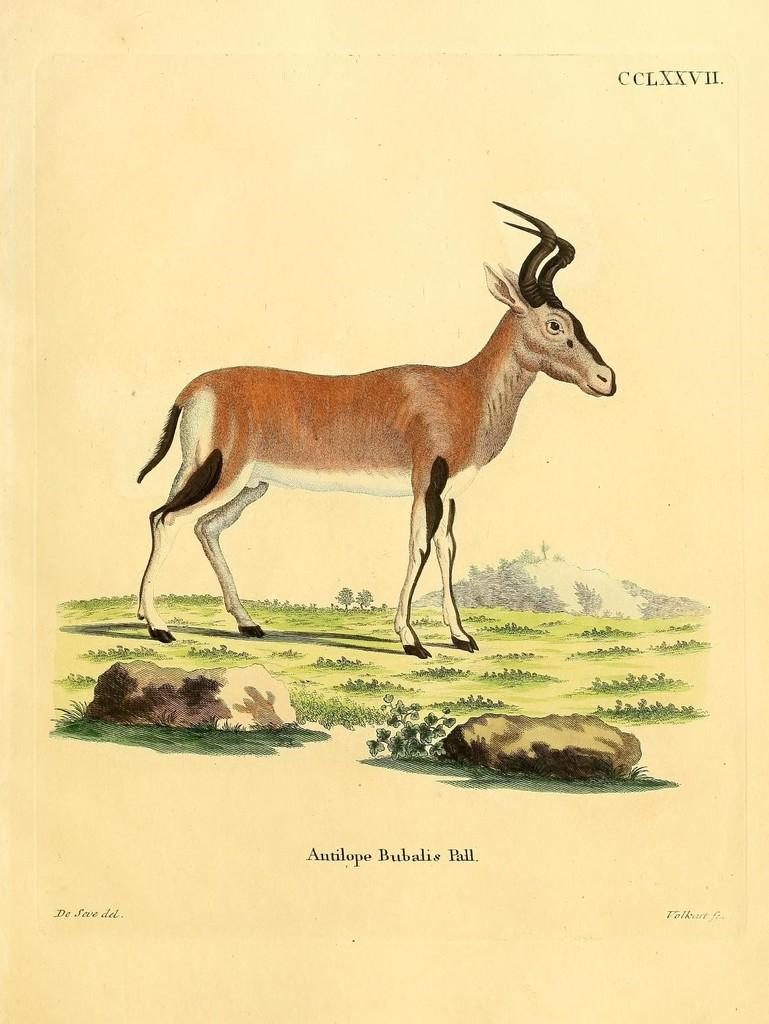What is the main subject of the image? There is a painting in the image. What is depicted in the painting? An animal is standing in the painting. What type of terrain is the animal standing on? The animal is on land with grass and rocks. What can be seen in the background of the painting? There is a hill in the background of the painting. What is written or displayed at the bottom of the image? There is text at the bottom of the image. What type of alarm can be heard going off in the image? There is no alarm present in the image; it is a painting with an animal, terrain, and text. How many clovers are visible in the image? There are no clovers present in the image; it features a painting with an animal, terrain, and text. 